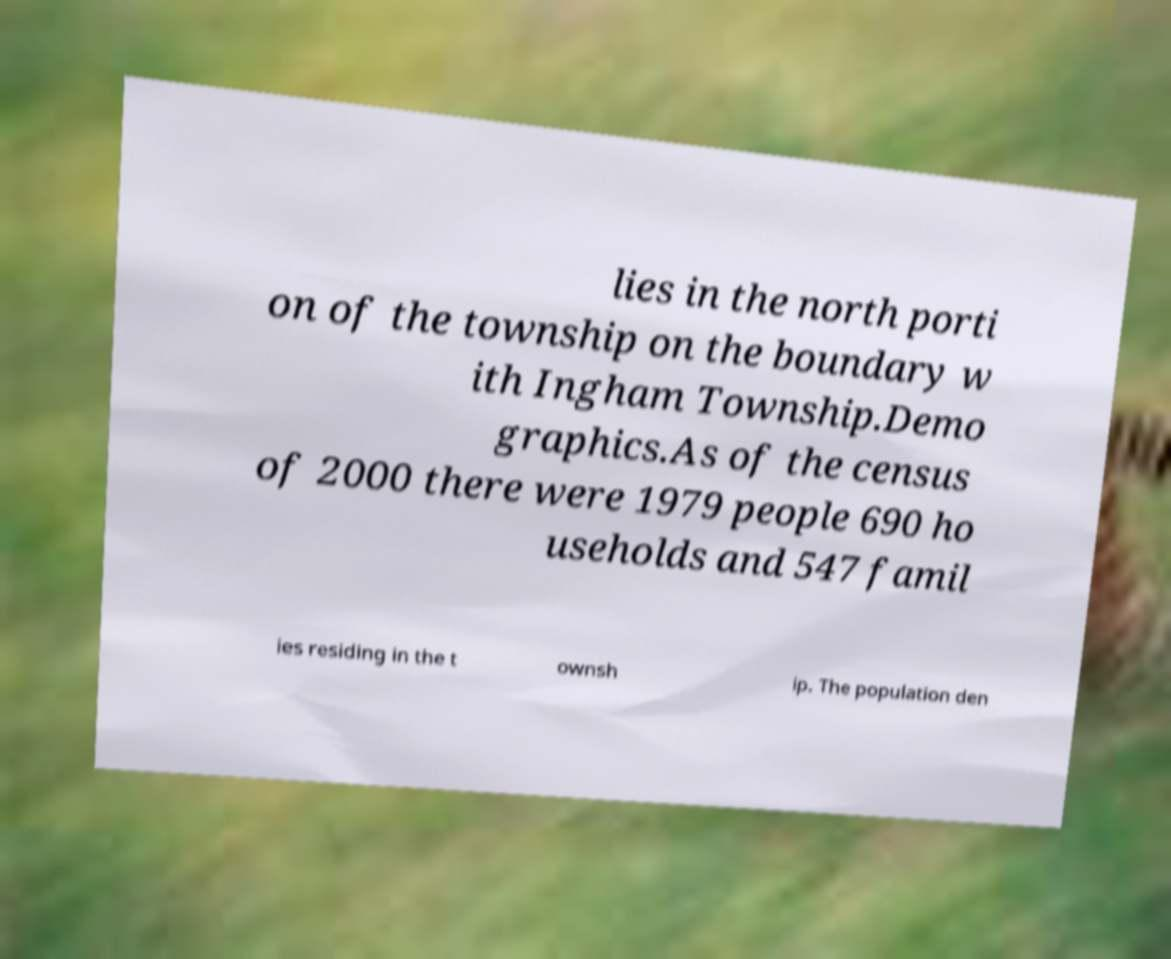What messages or text are displayed in this image? I need them in a readable, typed format. lies in the north porti on of the township on the boundary w ith Ingham Township.Demo graphics.As of the census of 2000 there were 1979 people 690 ho useholds and 547 famil ies residing in the t ownsh ip. The population den 